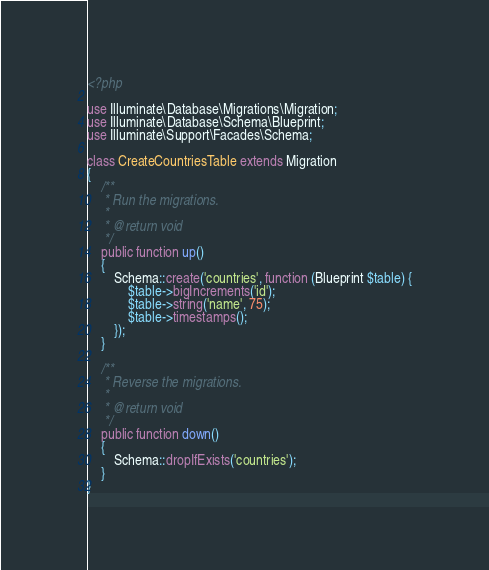Convert code to text. <code><loc_0><loc_0><loc_500><loc_500><_PHP_><?php

use Illuminate\Database\Migrations\Migration;
use Illuminate\Database\Schema\Blueprint;
use Illuminate\Support\Facades\Schema;

class CreateCountriesTable extends Migration
{
    /**
     * Run the migrations.
     *
     * @return void
     */
    public function up()
    {
        Schema::create('countries', function (Blueprint $table) {
            $table->bigIncrements('id');
            $table->string('name', 75);
            $table->timestamps();
        });
    }

    /**
     * Reverse the migrations.
     *
     * @return void
     */
    public function down()
    {
        Schema::dropIfExists('countries');
    }
}
</code> 